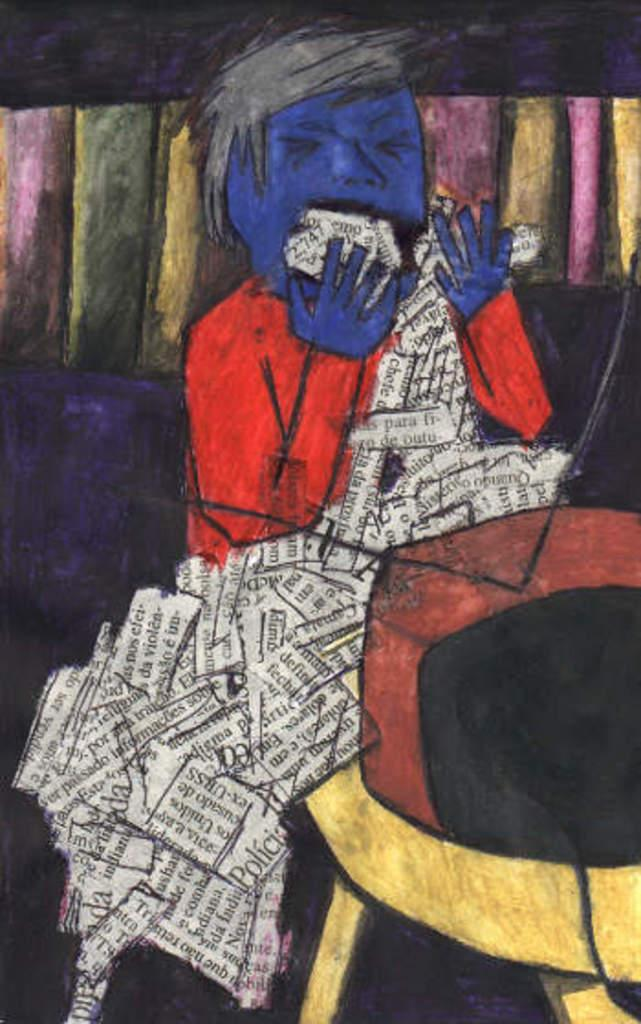What is the main subject of the image? There is an art piece in the image. What is depicted in the art piece? The art piece contains a person. Where is the pen located in the image? There is no pen present in the image. What type of home is shown in the art piece? The art piece does not depict a home; it contains a person. 